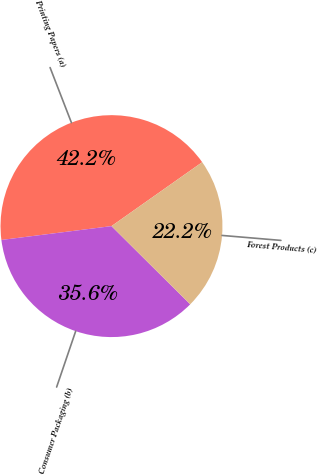Convert chart. <chart><loc_0><loc_0><loc_500><loc_500><pie_chart><fcel>Printing Papers (a)<fcel>Consumer Packaging (b)<fcel>Forest Products (c)<nl><fcel>42.22%<fcel>35.56%<fcel>22.22%<nl></chart> 